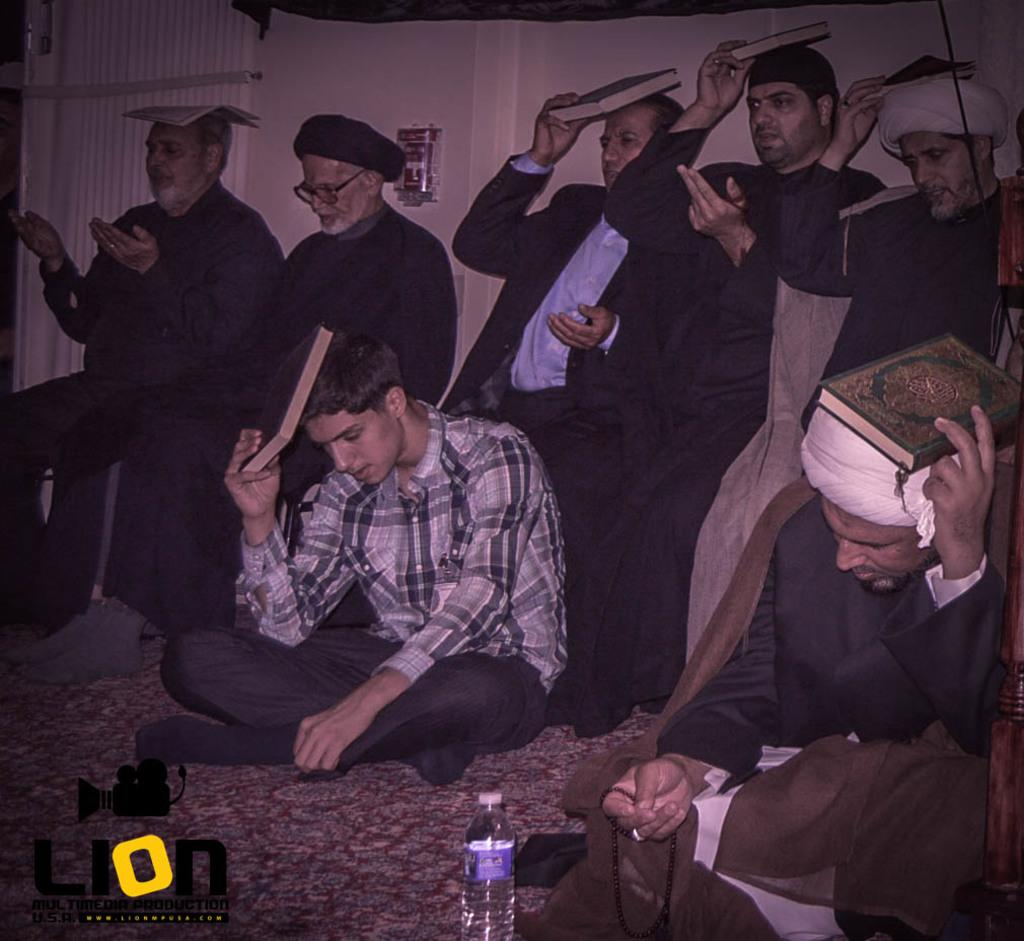What are the people in the image doing? The people in the image are sitting and holding books near their heads. What can be seen on the floor in the image? There is a bottle on the floor in the image. Is there any branding or logo visible in the image? Yes, there is a logo of a camera at the bottom of the image. What type of animal is making a statement in the image? There is no animal present in the image, and therefore no such statement can be made. 